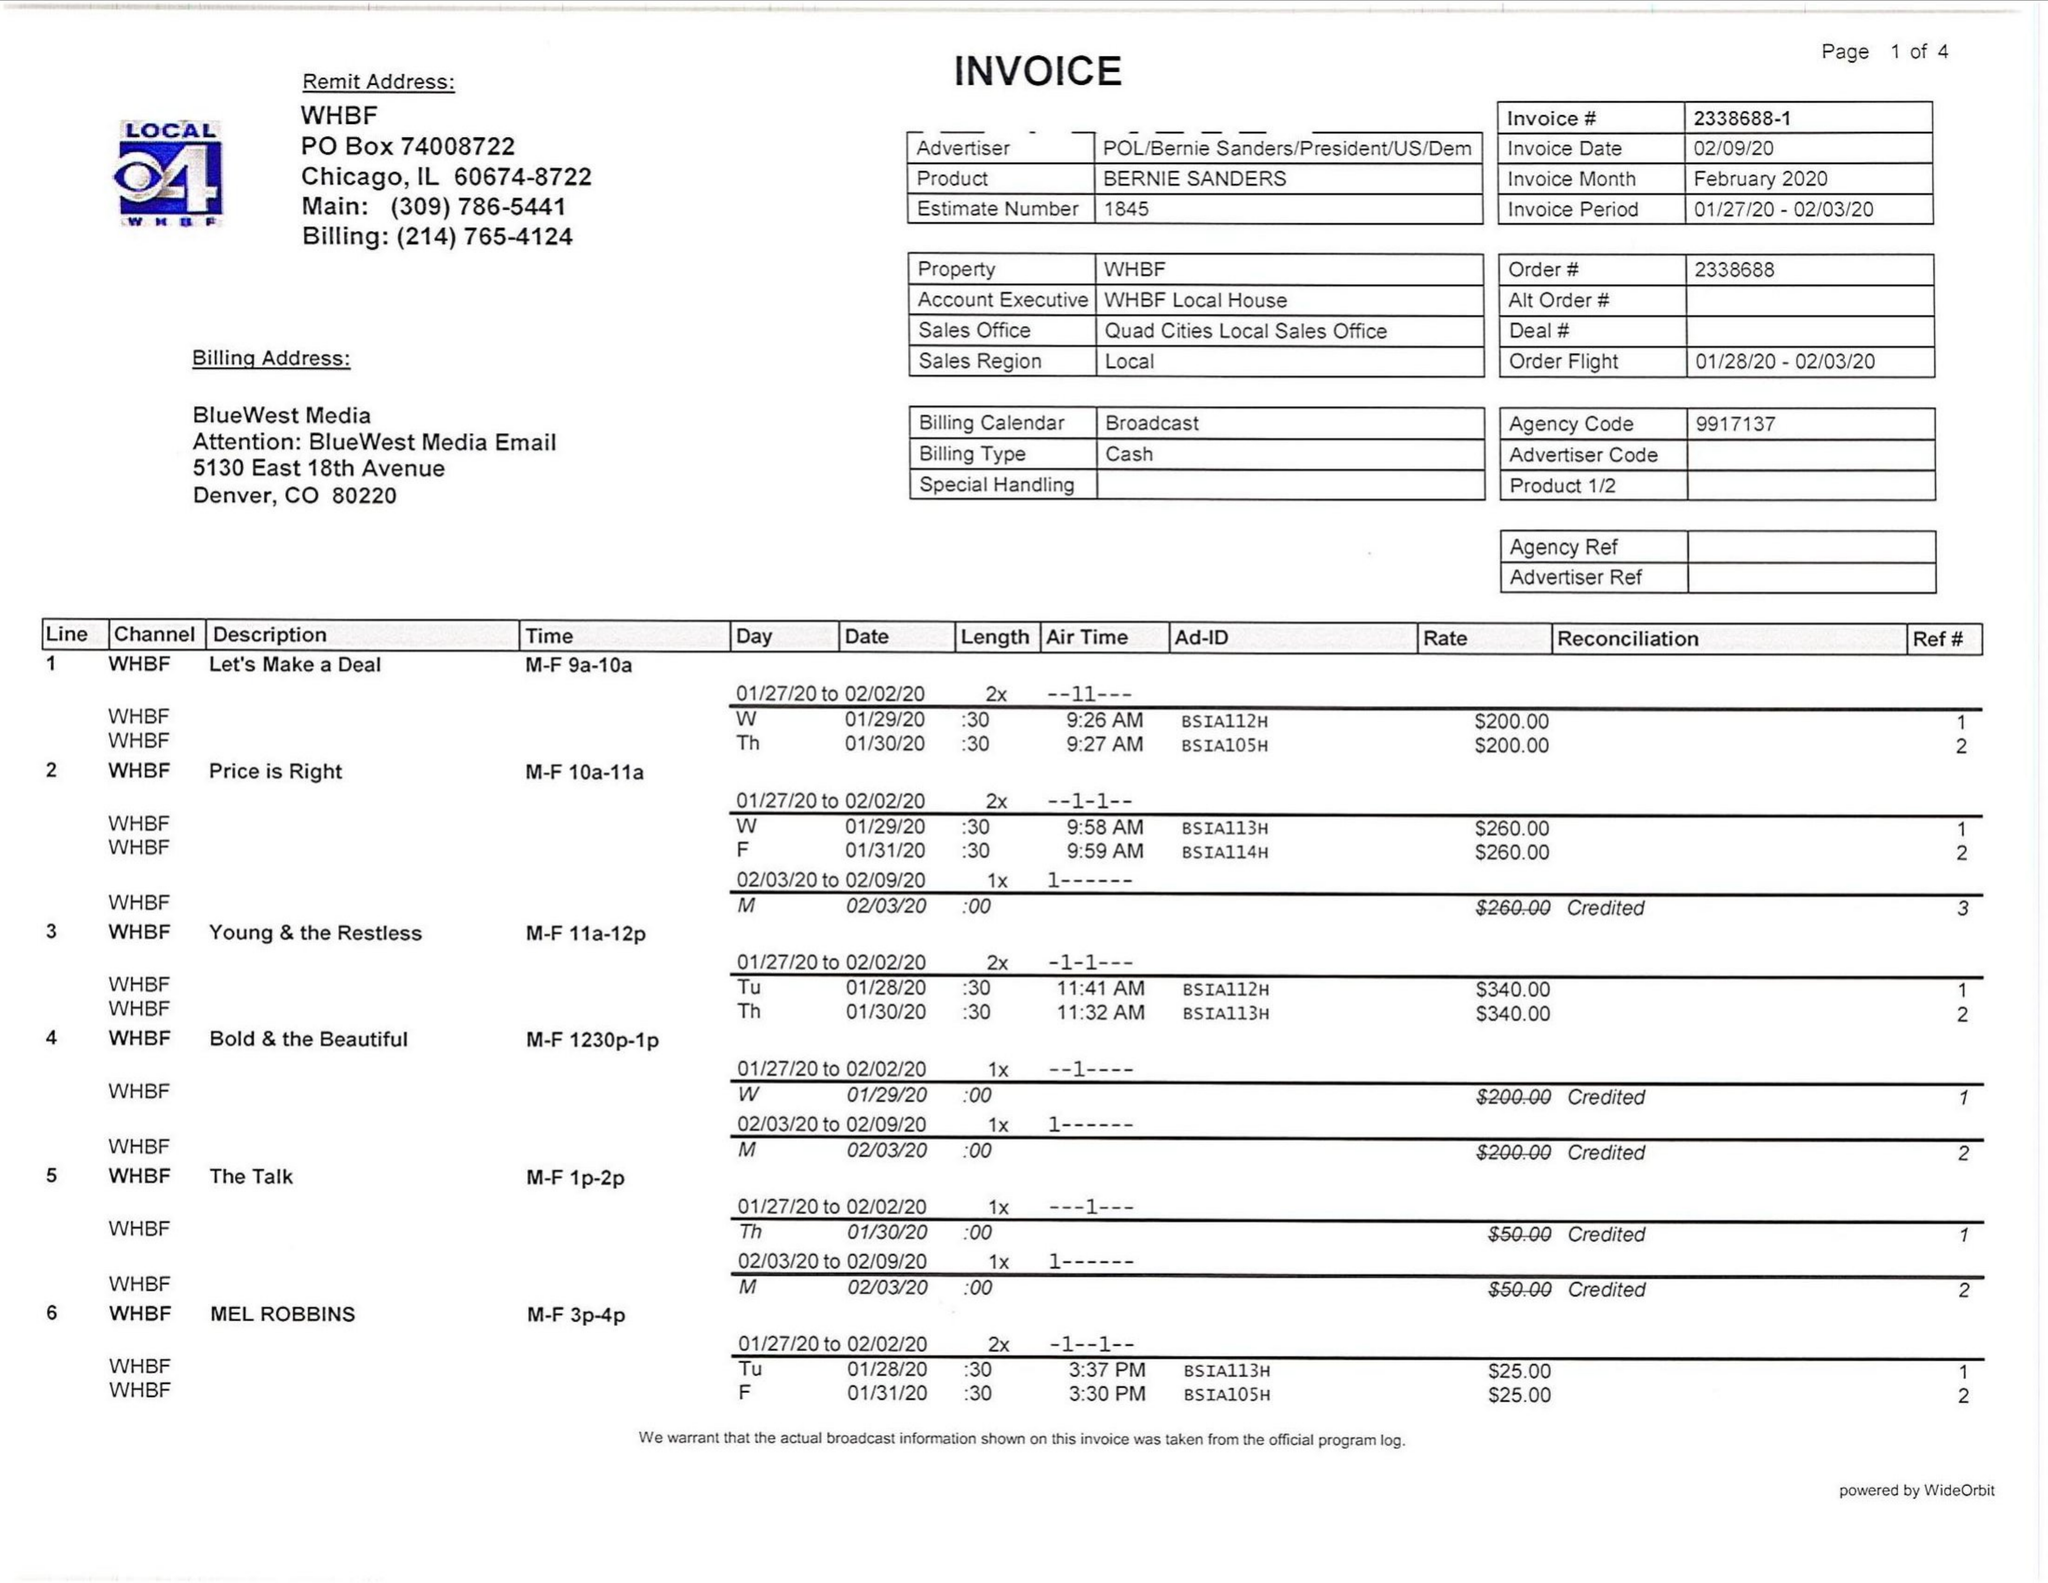What is the value for the gross_amount?
Answer the question using a single word or phrase. 8875.00 